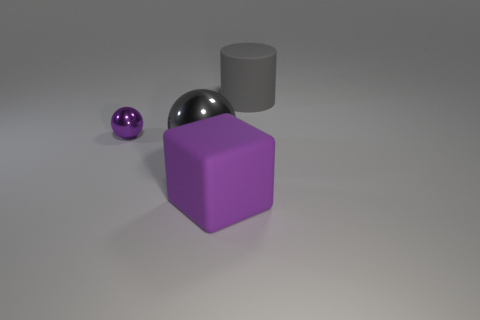Does this arrangement suggest any practical use or is it purely decorative? The arrangement of the shapes does not suggest any specific practical use; it appears to be a simple, aesthetic composition meant to showcase the shapes and their interplay with light. 